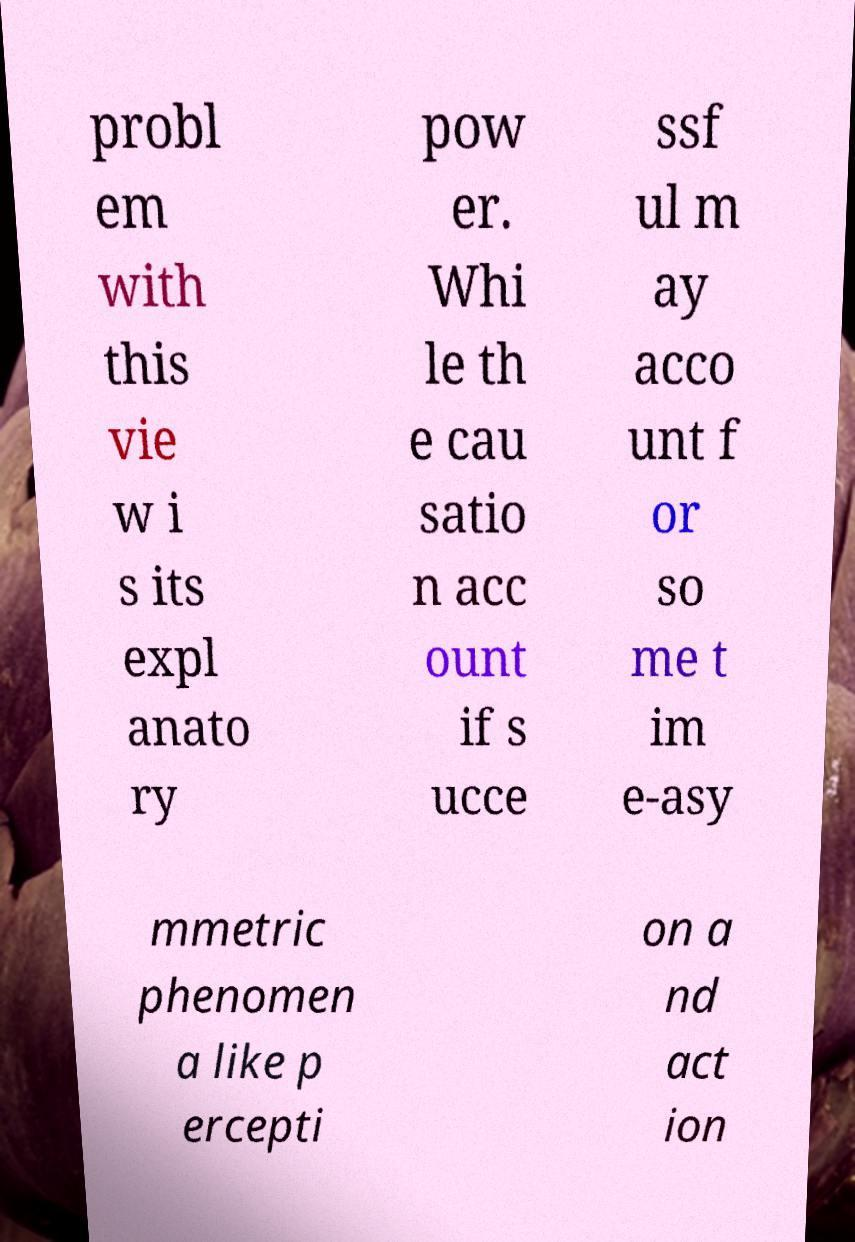For documentation purposes, I need the text within this image transcribed. Could you provide that? probl em with this vie w i s its expl anato ry pow er. Whi le th e cau satio n acc ount if s ucce ssf ul m ay acco unt f or so me t im e-asy mmetric phenomen a like p ercepti on a nd act ion 